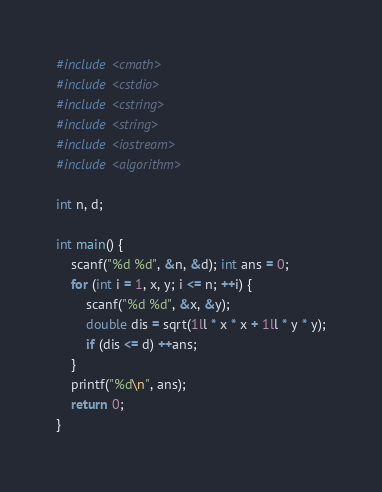<code> <loc_0><loc_0><loc_500><loc_500><_C_>#include <cmath>
#include <cstdio>
#include <cstring>
#include <string>
#include <iostream>
#include <algorithm>

int n, d;

int main() {
	scanf("%d %d", &n, &d); int ans = 0;
	for (int i = 1, x, y; i <= n; ++i) {
		scanf("%d %d", &x, &y);
		double dis = sqrt(1ll * x * x + 1ll * y * y);
		if (dis <= d) ++ans;
	}
	printf("%d\n", ans);
	return 0;
}</code> 